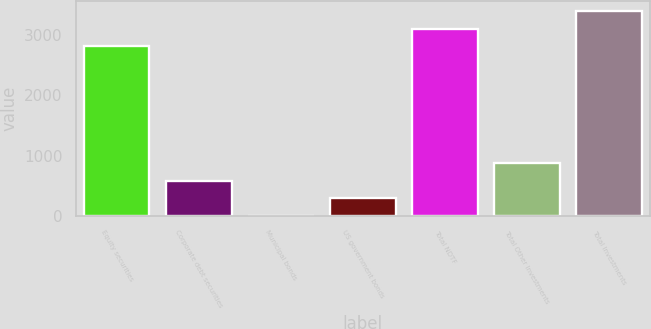Convert chart. <chart><loc_0><loc_0><loc_500><loc_500><bar_chart><fcel>Equity securities<fcel>Corporate debt securities<fcel>Municipal bonds<fcel>US government bonds<fcel>Total NDTF<fcel>Total Other Investments<fcel>Total Investments<nl><fcel>2805<fcel>583<fcel>4<fcel>293.5<fcel>3094.5<fcel>872.5<fcel>3384<nl></chart> 